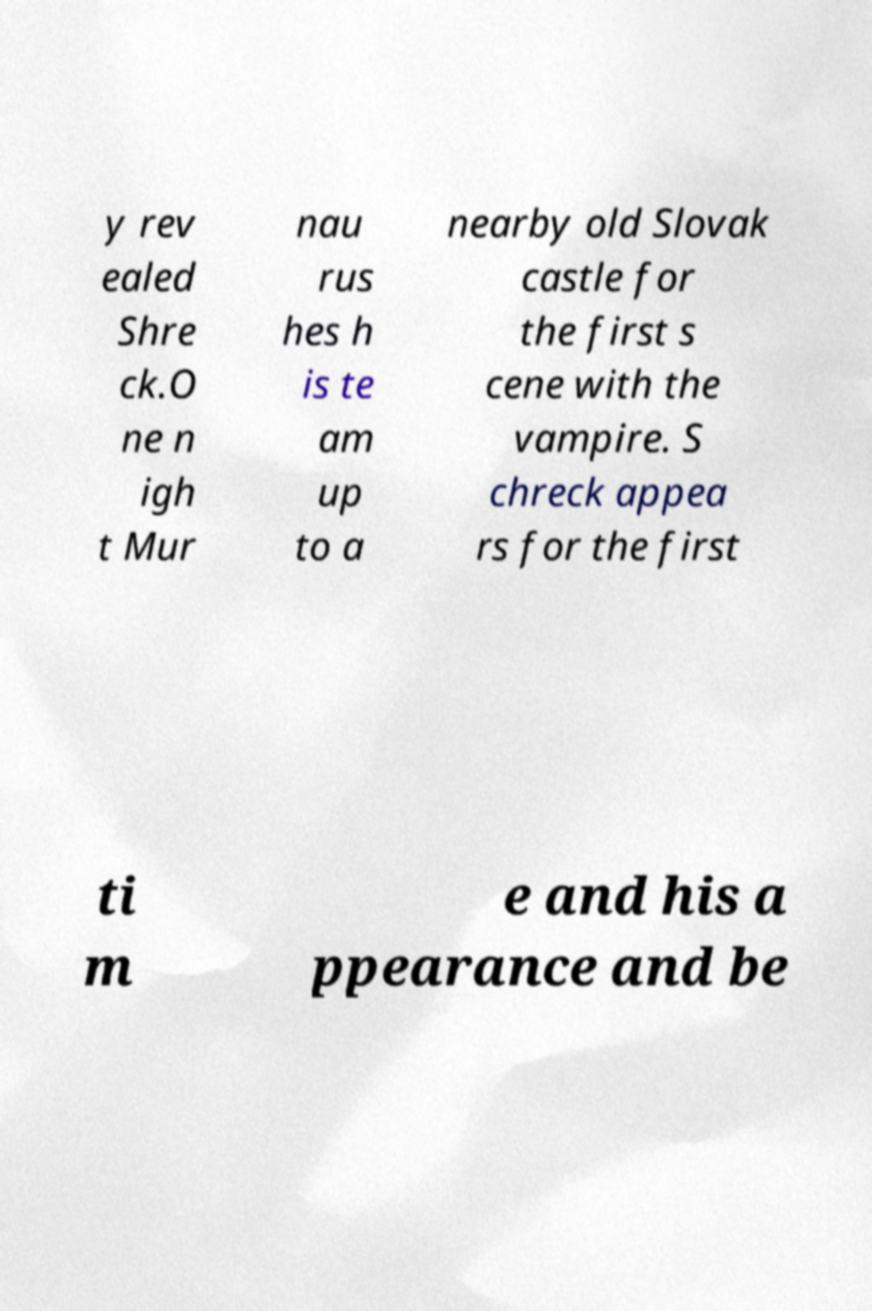I need the written content from this picture converted into text. Can you do that? y rev ealed Shre ck.O ne n igh t Mur nau rus hes h is te am up to a nearby old Slovak castle for the first s cene with the vampire. S chreck appea rs for the first ti m e and his a ppearance and be 